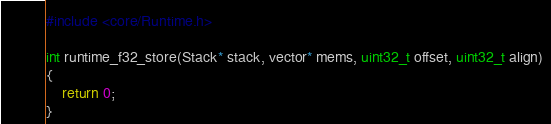Convert code to text. <code><loc_0><loc_0><loc_500><loc_500><_C_>#include <core/Runtime.h>

int runtime_f32_store(Stack* stack, vector* mems, uint32_t offset, uint32_t align)
{
    return 0;
}
</code> 